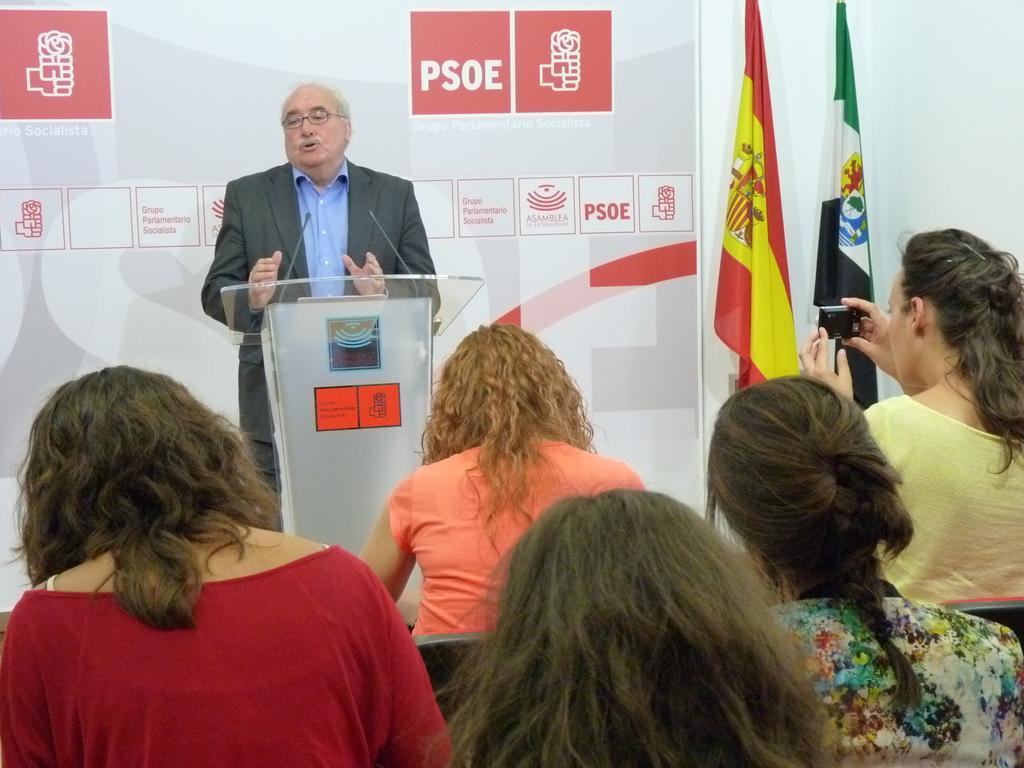How would you summarize this image in a sentence or two? In this image, we can see people and one of them is holding a camera and in the background, there are flags and we can see a person wearing a coat and glasses and we can see a podium and mics and there is a board on the wall. 